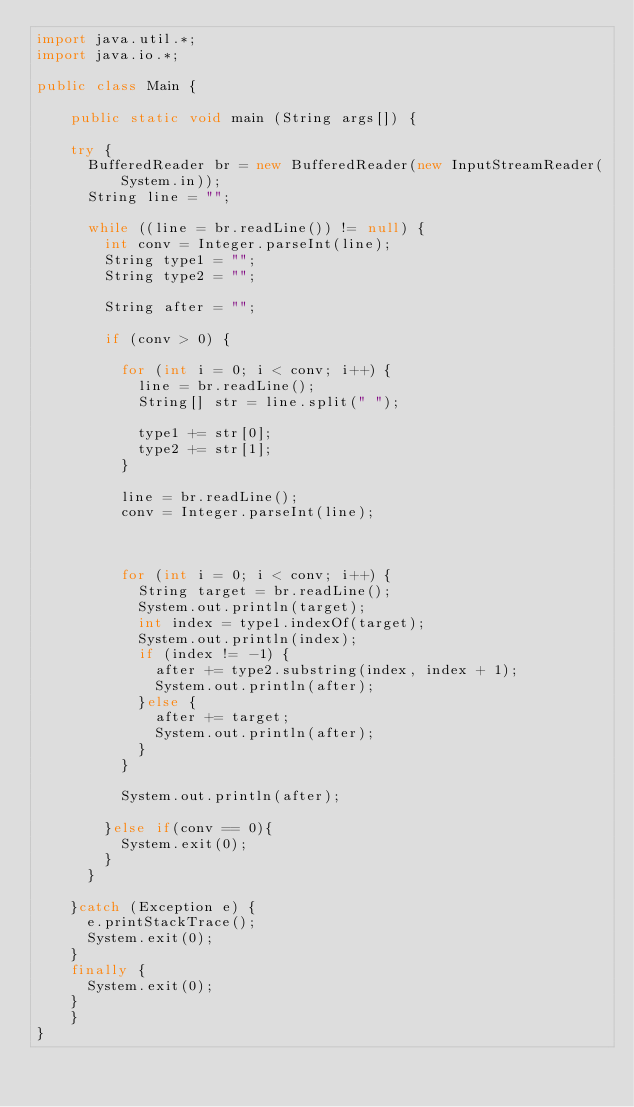<code> <loc_0><loc_0><loc_500><loc_500><_Java_>import java.util.*;
import java.io.*;

public class Main {

    public static void main (String args[]) {
        
		try {
			BufferedReader br = new BufferedReader(new InputStreamReader(System.in));
			String line = "";
			
			while ((line = br.readLine()) != null) {
				int conv = Integer.parseInt(line);
				String type1 = "";
				String type2 = "";
				
				String after = "";
				
				if (conv > 0) {
					
					for (int i = 0; i < conv; i++) {
						line = br.readLine();
						String[] str = line.split(" ");
						
						type1 += str[0];
						type2 += str[1];
					}
					
					line = br.readLine();
					conv = Integer.parseInt(line);

					

					for (int i = 0; i < conv; i++) {
						String target = br.readLine();
						System.out.println(target);
						int index = type1.indexOf(target);
						System.out.println(index);
						if (index != -1) {
							after += type2.substring(index, index + 1);
							System.out.println(after);
						}else {
							after += target;
							System.out.println(after);
						}						
					}
					
					System.out.println(after);
					
				}else if(conv == 0){
					System.exit(0);
				}
			}
			
		}catch (Exception e) {
			e.printStackTrace();
			System.exit(0);
		}
		finally {
			System.exit(0);
		}
    }
}</code> 